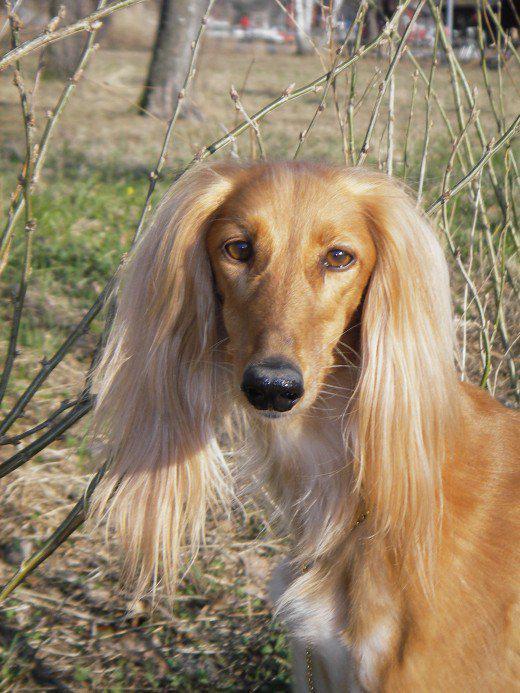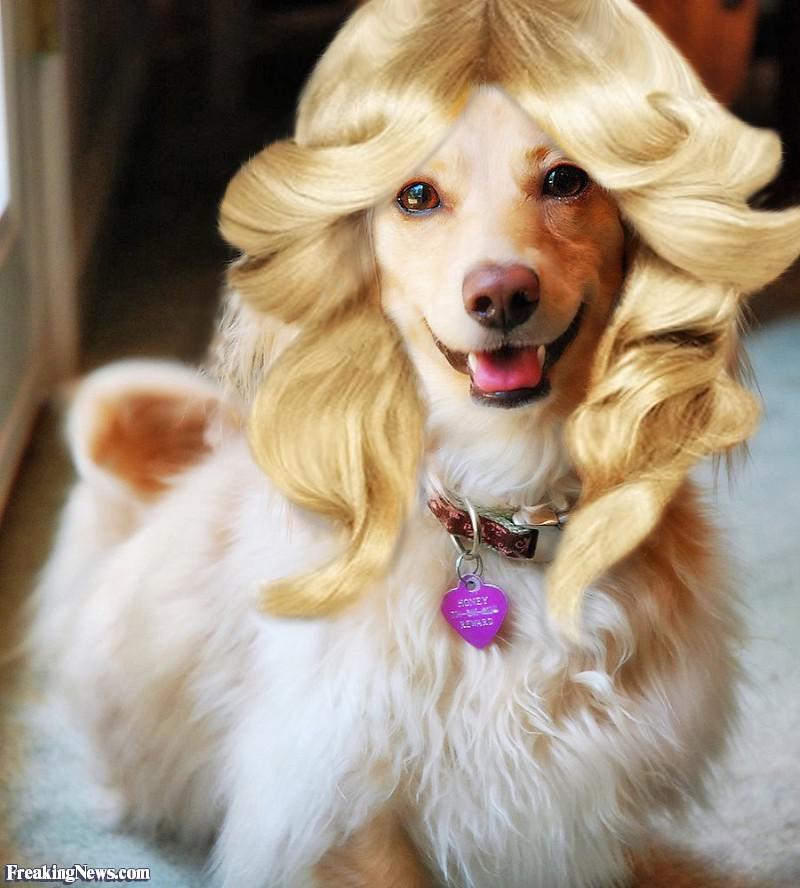The first image is the image on the left, the second image is the image on the right. Assess this claim about the two images: "A dog is wearing something around its neck.". Correct or not? Answer yes or no. Yes. The first image is the image on the left, the second image is the image on the right. For the images displayed, is the sentence "The dog on the left has its muzzle pointing slightly rightward, and the dog on the right has a darker muzzle that the rest of its fur or the dog on the left." factually correct? Answer yes or no. No. 